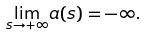Convert formula to latex. <formula><loc_0><loc_0><loc_500><loc_500>\underset { s \rightarrow + \infty } { \lim } a ( s ) = - \infty .</formula> 